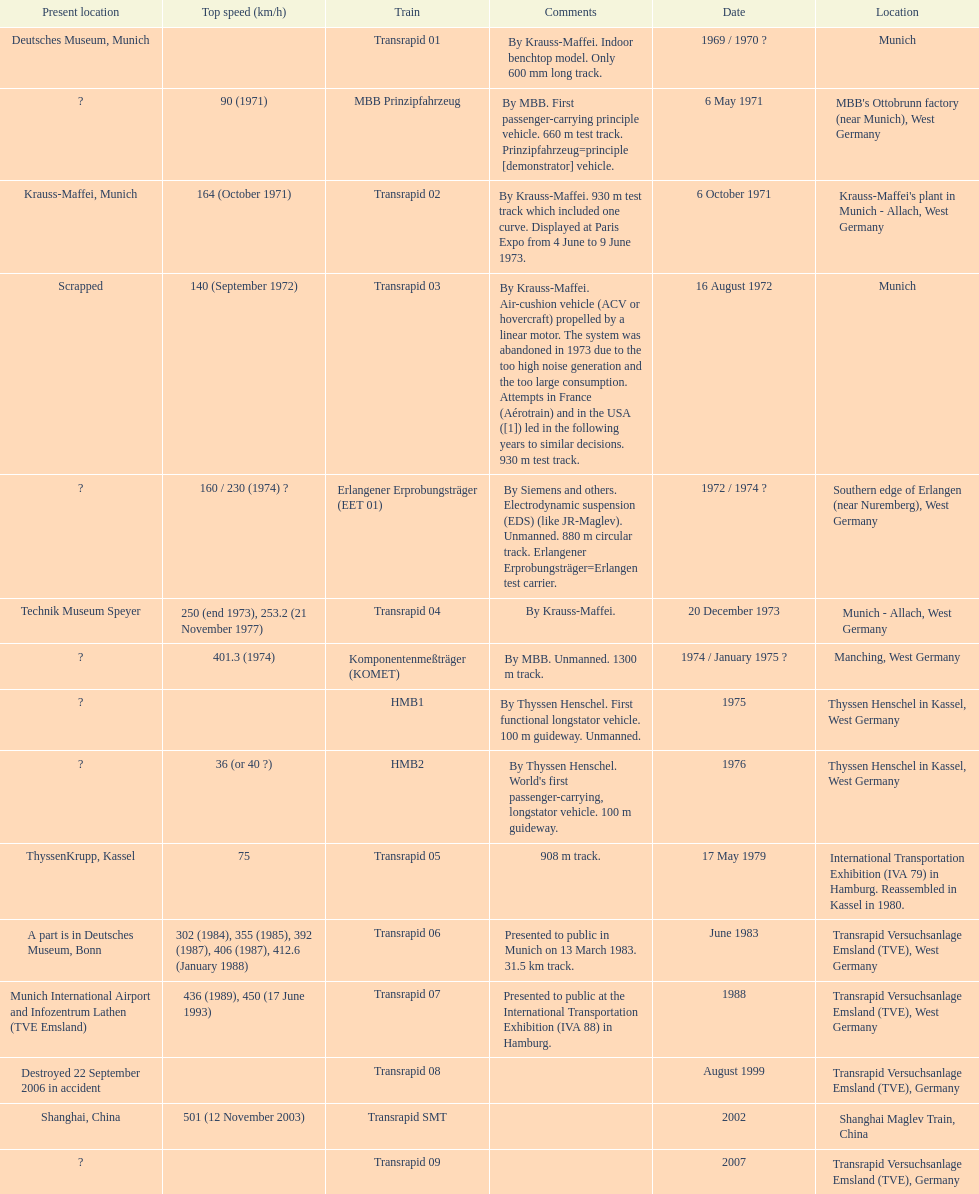How many trains other than the transrapid 07 can go faster than 450km/h? 1. 